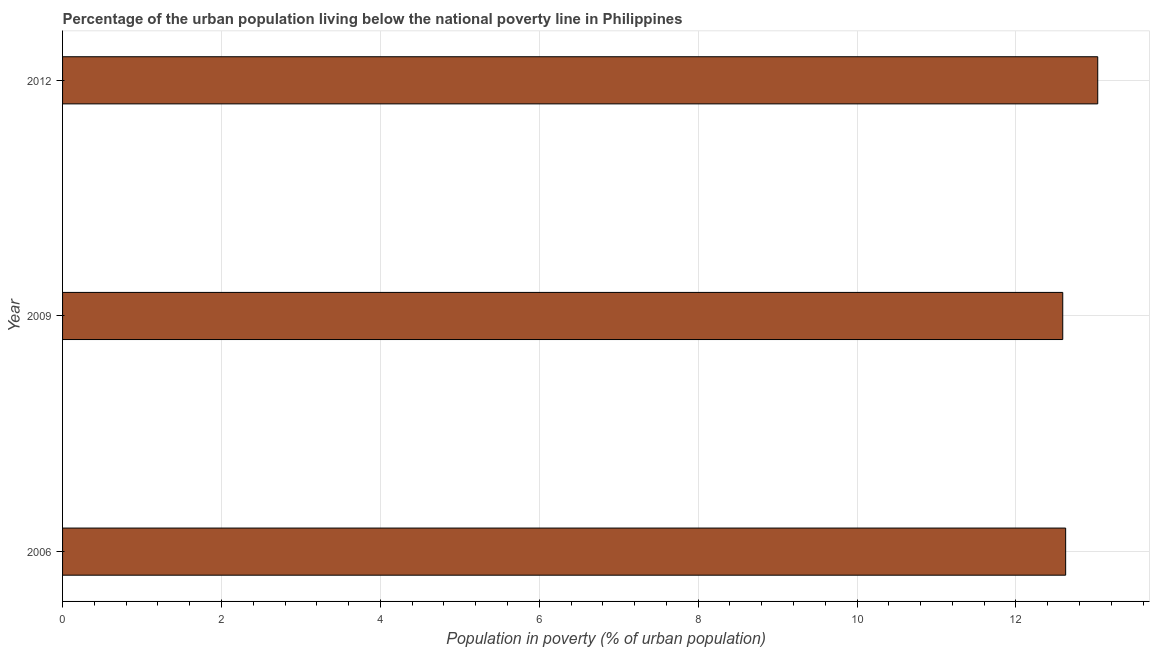What is the title of the graph?
Make the answer very short. Percentage of the urban population living below the national poverty line in Philippines. What is the label or title of the X-axis?
Make the answer very short. Population in poverty (% of urban population). What is the label or title of the Y-axis?
Keep it short and to the point. Year. What is the percentage of urban population living below poverty line in 2006?
Keep it short and to the point. 12.63. Across all years, what is the maximum percentage of urban population living below poverty line?
Give a very brief answer. 13.03. Across all years, what is the minimum percentage of urban population living below poverty line?
Offer a terse response. 12.59. In which year was the percentage of urban population living below poverty line minimum?
Make the answer very short. 2009. What is the sum of the percentage of urban population living below poverty line?
Your answer should be very brief. 38.25. What is the difference between the percentage of urban population living below poverty line in 2006 and 2009?
Keep it short and to the point. 0.04. What is the average percentage of urban population living below poverty line per year?
Offer a very short reply. 12.75. What is the median percentage of urban population living below poverty line?
Your response must be concise. 12.63. What is the ratio of the percentage of urban population living below poverty line in 2006 to that in 2009?
Make the answer very short. 1. What is the difference between the highest and the second highest percentage of urban population living below poverty line?
Offer a terse response. 0.4. What is the difference between the highest and the lowest percentage of urban population living below poverty line?
Your answer should be compact. 0.44. How many bars are there?
Keep it short and to the point. 3. What is the difference between two consecutive major ticks on the X-axis?
Make the answer very short. 2. Are the values on the major ticks of X-axis written in scientific E-notation?
Make the answer very short. No. What is the Population in poverty (% of urban population) of 2006?
Provide a succinct answer. 12.63. What is the Population in poverty (% of urban population) in 2009?
Your response must be concise. 12.59. What is the Population in poverty (% of urban population) of 2012?
Ensure brevity in your answer.  13.03. What is the difference between the Population in poverty (% of urban population) in 2006 and 2009?
Your answer should be compact. 0.04. What is the difference between the Population in poverty (% of urban population) in 2006 and 2012?
Provide a short and direct response. -0.4. What is the difference between the Population in poverty (% of urban population) in 2009 and 2012?
Provide a succinct answer. -0.44. What is the ratio of the Population in poverty (% of urban population) in 2009 to that in 2012?
Provide a succinct answer. 0.97. 